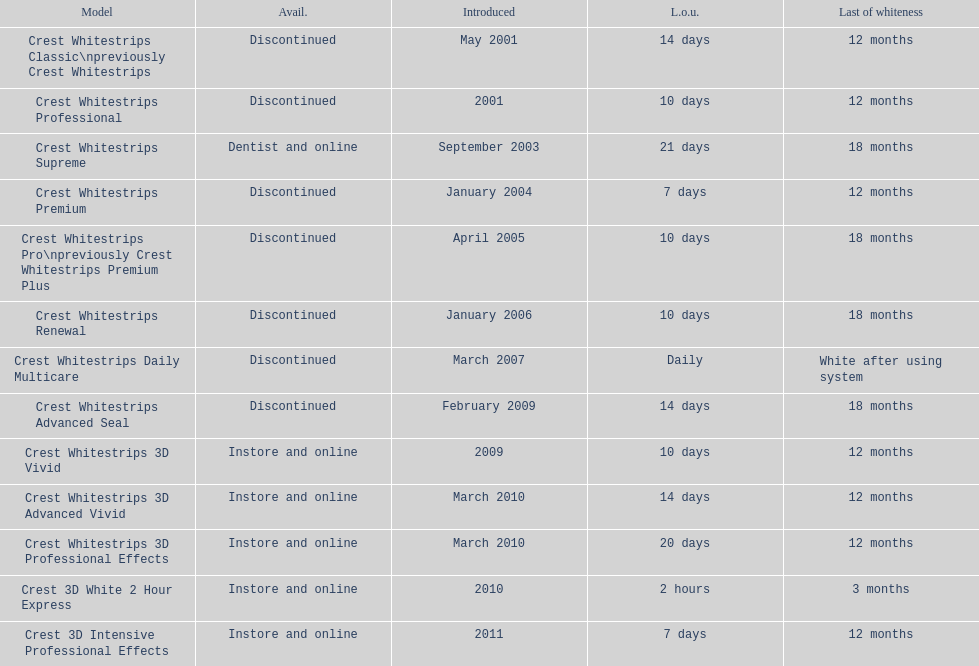Which product was to be used longer, crest whitestrips classic or crest whitestrips 3d vivid? Crest Whitestrips Classic. 